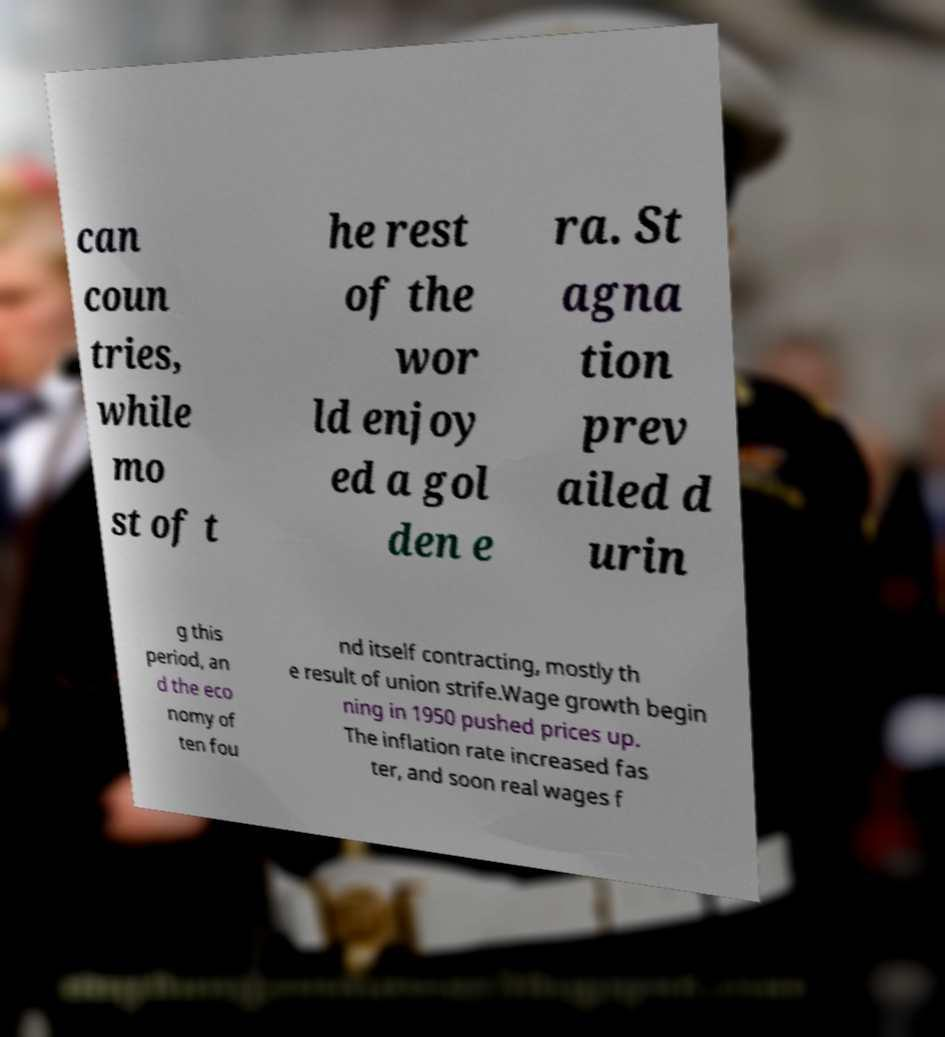Could you extract and type out the text from this image? can coun tries, while mo st of t he rest of the wor ld enjoy ed a gol den e ra. St agna tion prev ailed d urin g this period, an d the eco nomy of ten fou nd itself contracting, mostly th e result of union strife.Wage growth begin ning in 1950 pushed prices up. The inflation rate increased fas ter, and soon real wages f 